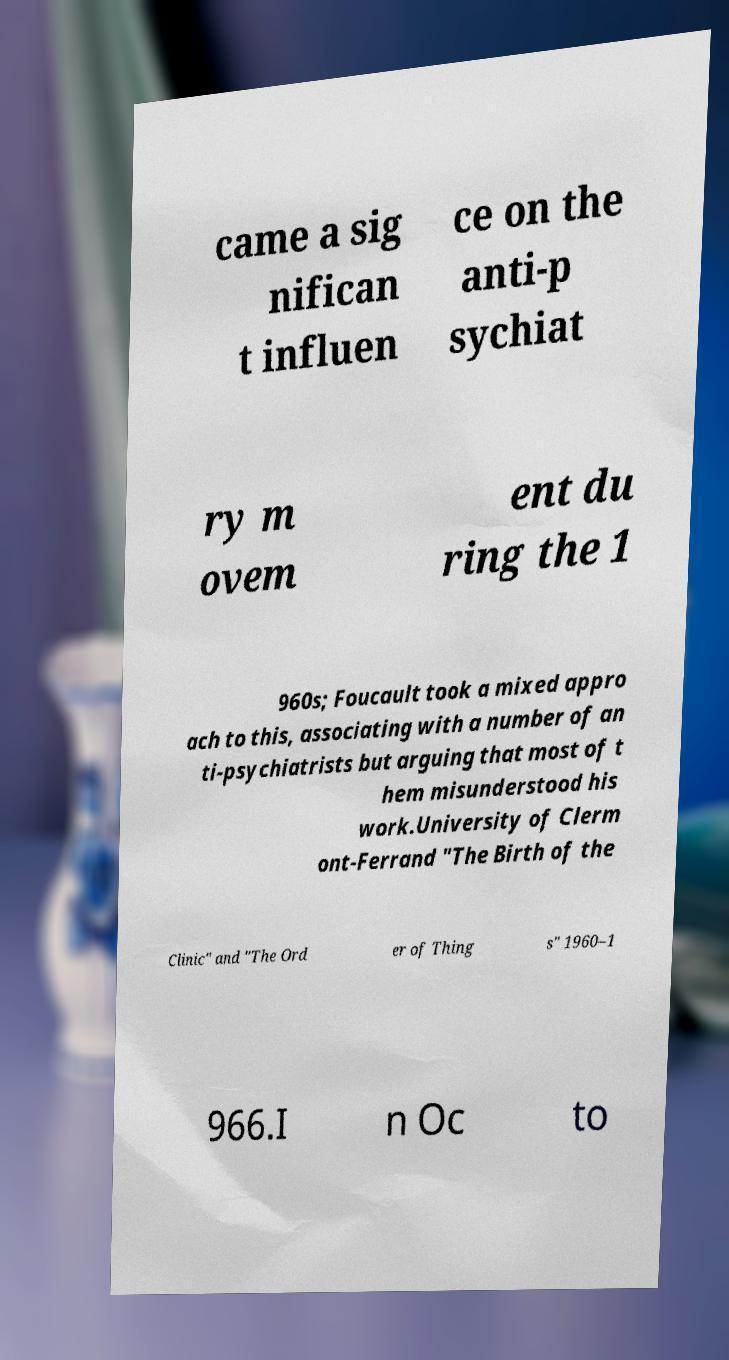There's text embedded in this image that I need extracted. Can you transcribe it verbatim? came a sig nifican t influen ce on the anti-p sychiat ry m ovem ent du ring the 1 960s; Foucault took a mixed appro ach to this, associating with a number of an ti-psychiatrists but arguing that most of t hem misunderstood his work.University of Clerm ont-Ferrand "The Birth of the Clinic" and "The Ord er of Thing s" 1960–1 966.I n Oc to 